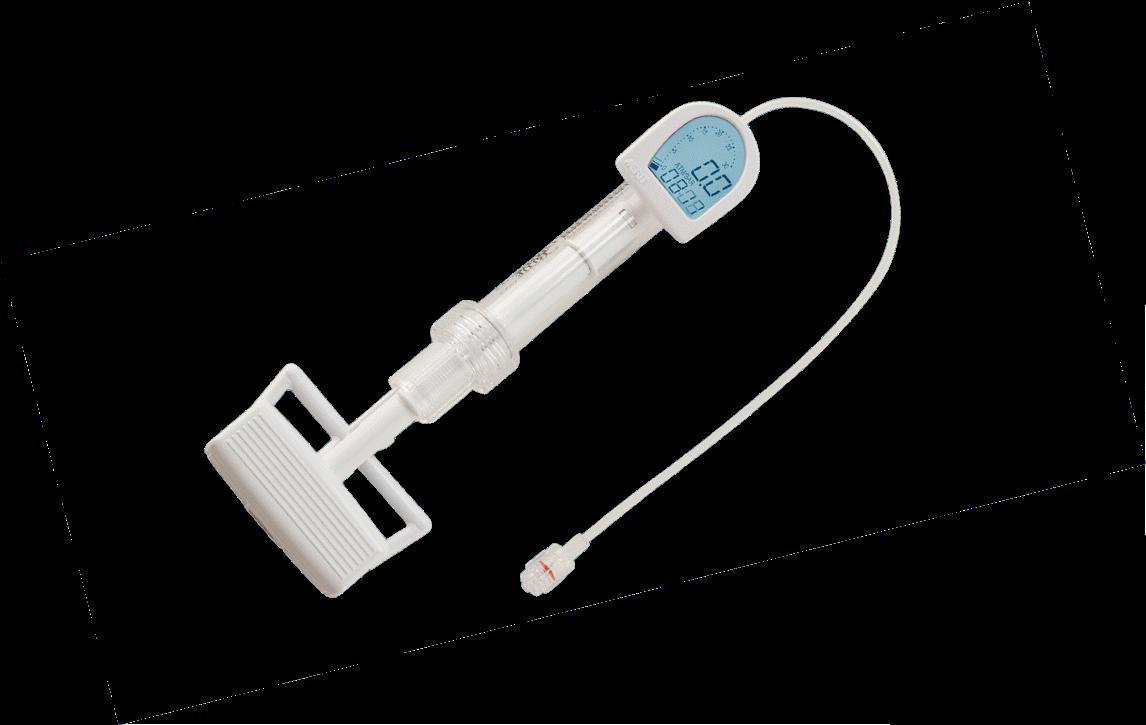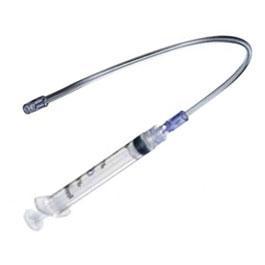The first image is the image on the left, the second image is the image on the right. Examine the images to the left and right. Is the description "There are two pieces of flexible tubing in the image on the right." accurate? Answer yes or no. No. 